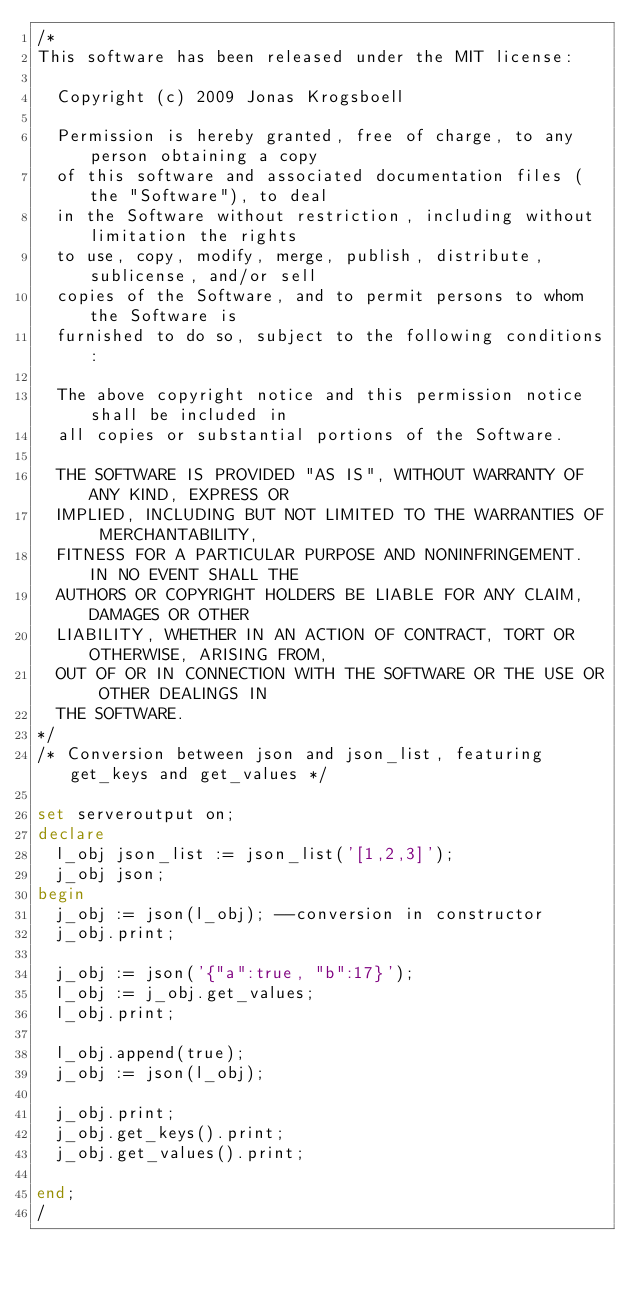<code> <loc_0><loc_0><loc_500><loc_500><_SQL_>/*
This software has been released under the MIT license:

  Copyright (c) 2009 Jonas Krogsboell

  Permission is hereby granted, free of charge, to any person obtaining a copy
  of this software and associated documentation files (the "Software"), to deal
  in the Software without restriction, including without limitation the rights
  to use, copy, modify, merge, publish, distribute, sublicense, and/or sell
  copies of the Software, and to permit persons to whom the Software is
  furnished to do so, subject to the following conditions:

  The above copyright notice and this permission notice shall be included in
  all copies or substantial portions of the Software.

  THE SOFTWARE IS PROVIDED "AS IS", WITHOUT WARRANTY OF ANY KIND, EXPRESS OR
  IMPLIED, INCLUDING BUT NOT LIMITED TO THE WARRANTIES OF MERCHANTABILITY,
  FITNESS FOR A PARTICULAR PURPOSE AND NONINFRINGEMENT. IN NO EVENT SHALL THE
  AUTHORS OR COPYRIGHT HOLDERS BE LIABLE FOR ANY CLAIM, DAMAGES OR OTHER
  LIABILITY, WHETHER IN AN ACTION OF CONTRACT, TORT OR OTHERWISE, ARISING FROM,
  OUT OF OR IN CONNECTION WITH THE SOFTWARE OR THE USE OR OTHER DEALINGS IN
  THE SOFTWARE.
*/
/* Conversion between json and json_list, featuring get_keys and get_values */

set serveroutput on;
declare 
  l_obj json_list := json_list('[1,2,3]');
  j_obj json;
begin
  j_obj := json(l_obj); --conversion in constructor
  j_obj.print;
  
  j_obj := json('{"a":true, "b":17}');
  l_obj := j_obj.get_values;
  l_obj.print;
  
  l_obj.append(true);
  j_obj := json(l_obj);
  
  j_obj.print;
  j_obj.get_keys().print;
  j_obj.get_values().print;
 
end;
/</code> 